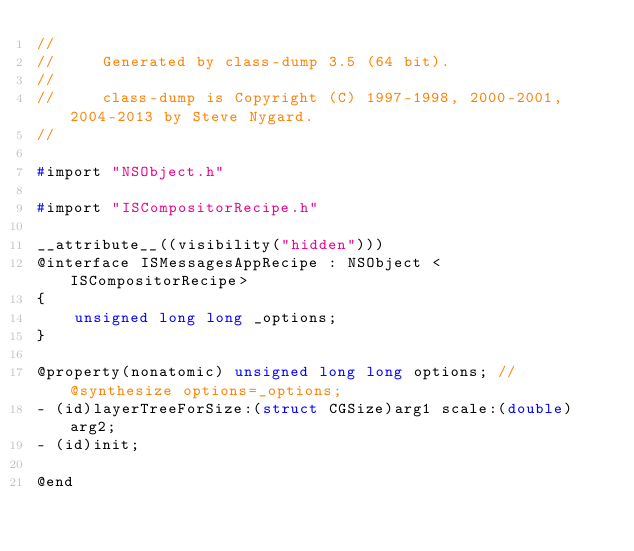<code> <loc_0><loc_0><loc_500><loc_500><_C_>//
//     Generated by class-dump 3.5 (64 bit).
//
//     class-dump is Copyright (C) 1997-1998, 2000-2001, 2004-2013 by Steve Nygard.
//

#import "NSObject.h"

#import "ISCompositorRecipe.h"

__attribute__((visibility("hidden")))
@interface ISMessagesAppRecipe : NSObject <ISCompositorRecipe>
{
    unsigned long long _options;
}

@property(nonatomic) unsigned long long options; // @synthesize options=_options;
- (id)layerTreeForSize:(struct CGSize)arg1 scale:(double)arg2;
- (id)init;

@end

</code> 